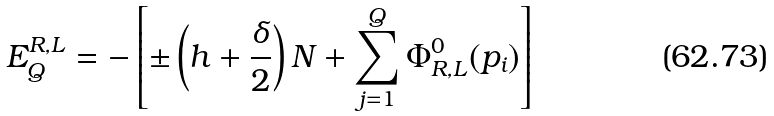<formula> <loc_0><loc_0><loc_500><loc_500>E _ { Q } ^ { R , L } = - \left [ \pm \left ( h + \frac { \delta } { 2 } \right ) N + \sum _ { j = 1 } ^ { Q } \Phi ^ { 0 } _ { R , L } ( p _ { i } ) \right ]</formula> 